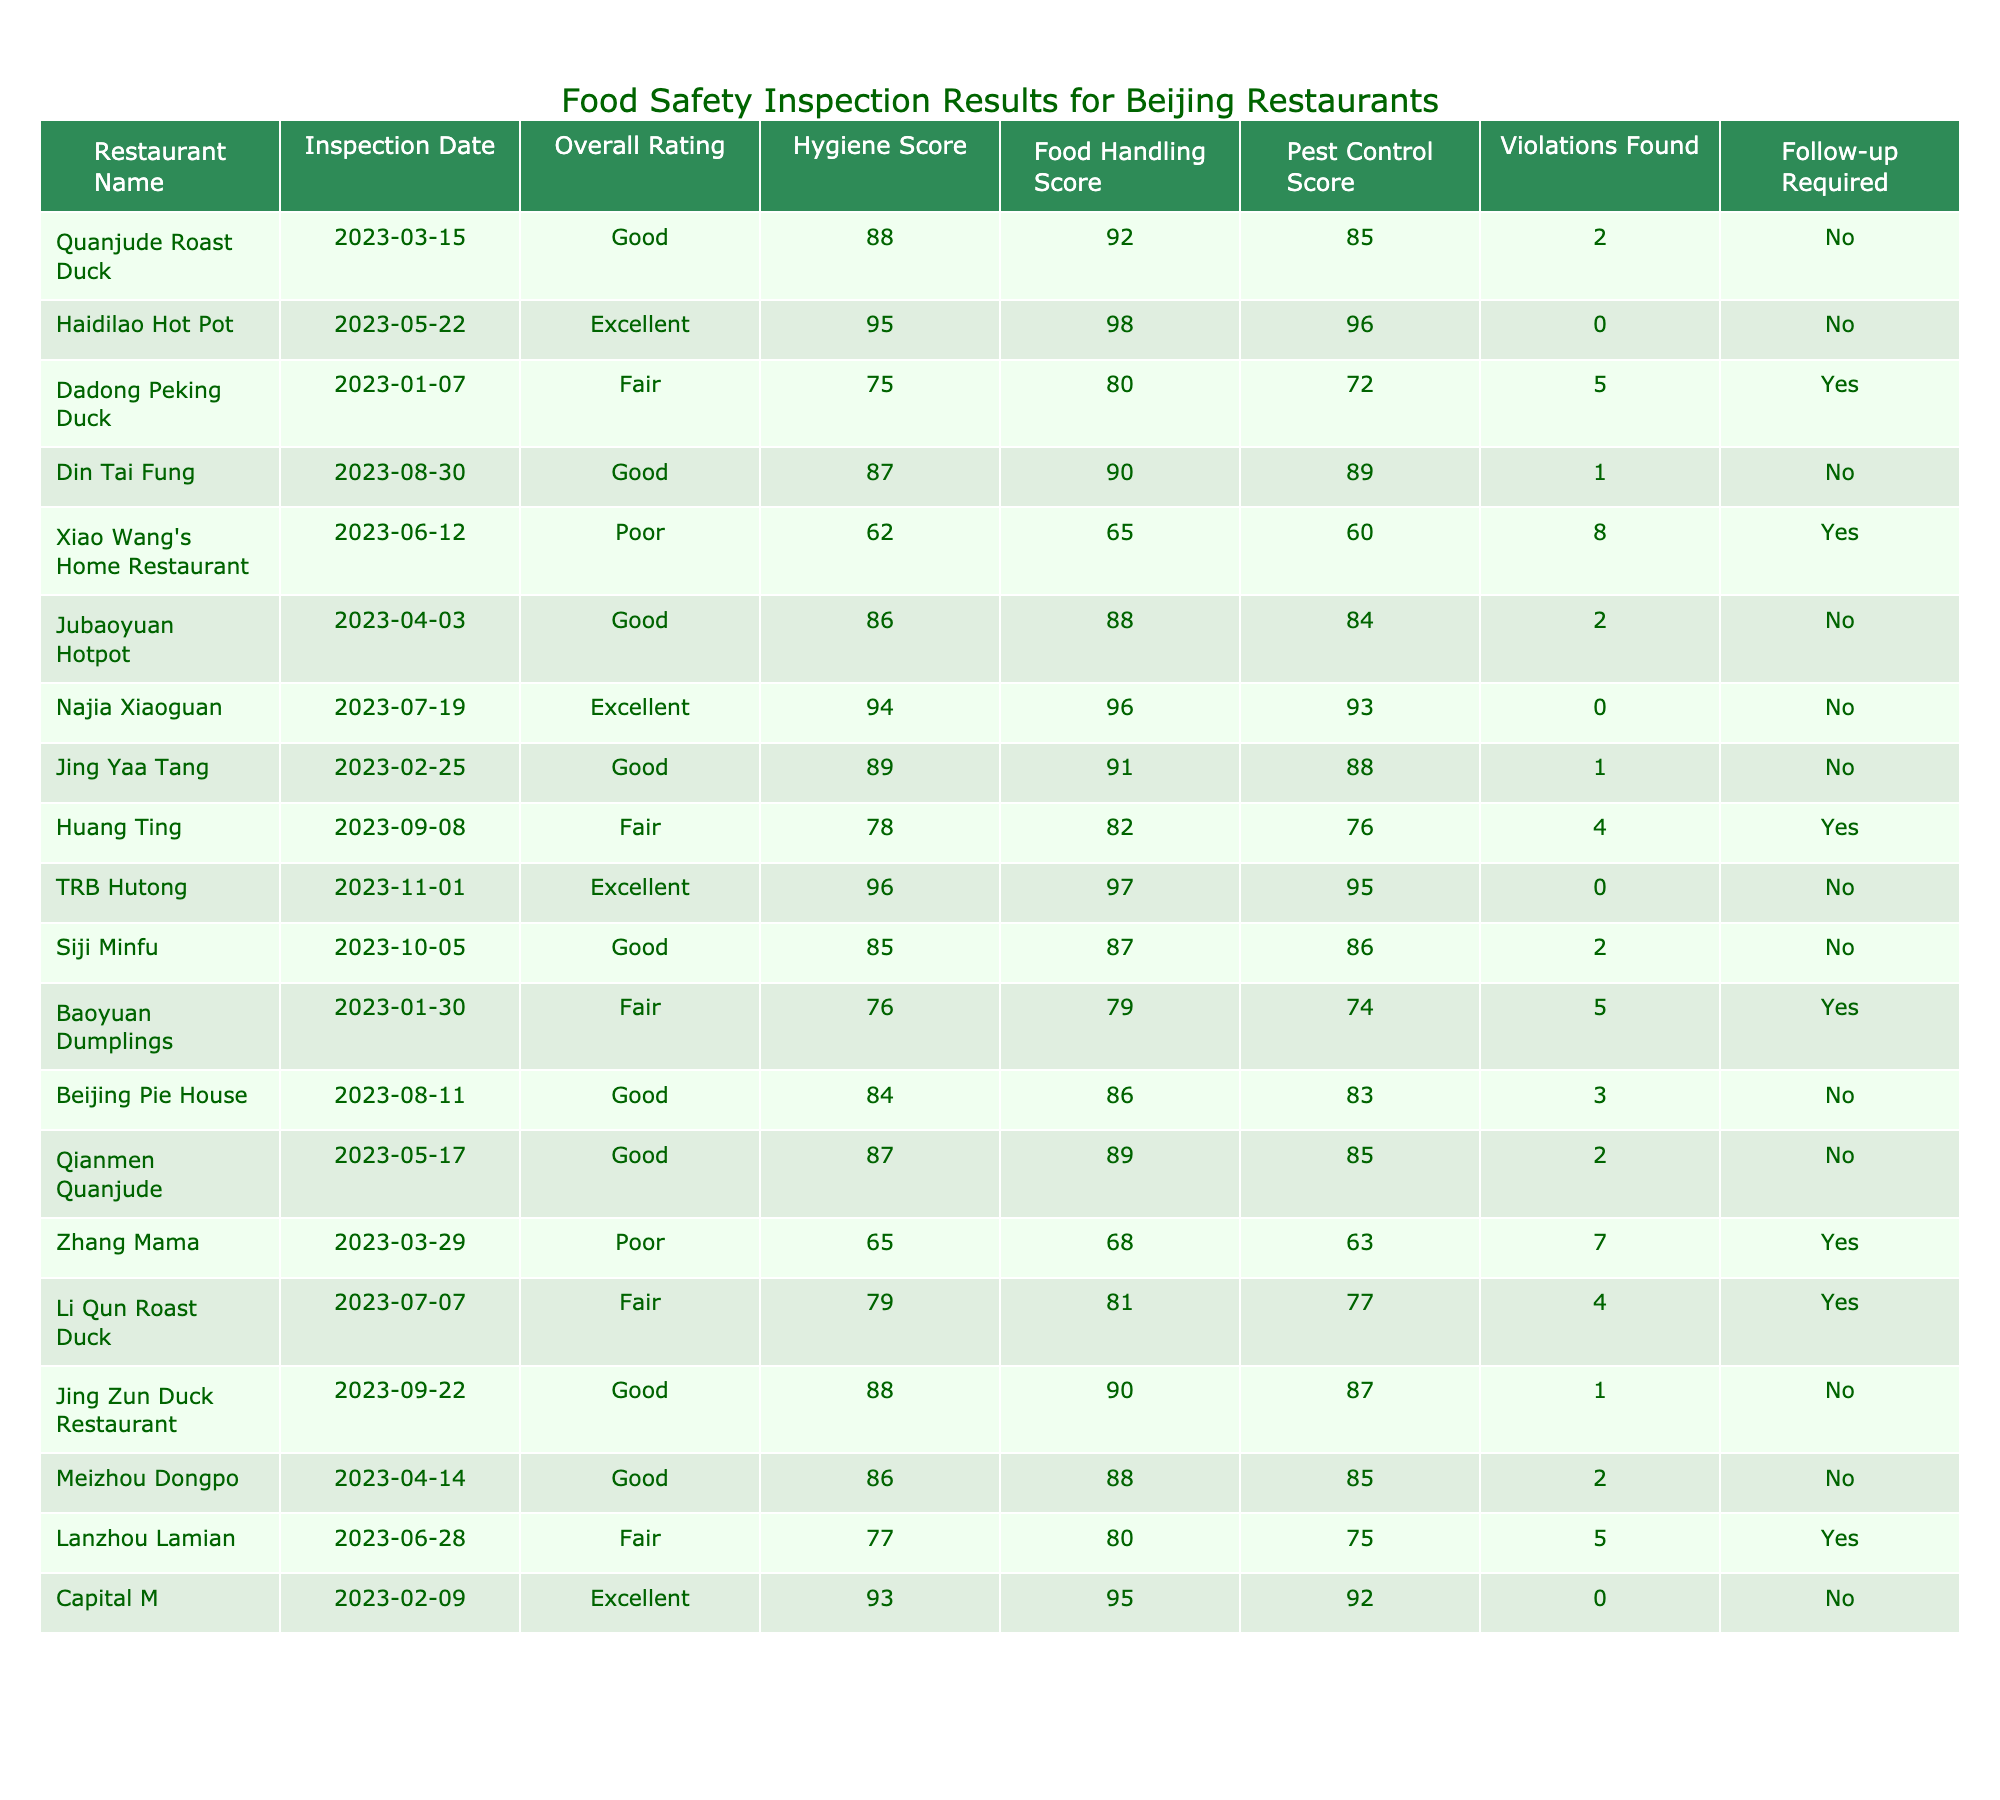What is the overall rating of Haidilao Hot Pot? Haidilao Hot Pot has an overall rating of 'Excellent' as indicated in its entry in the table.
Answer: Excellent How many restaurants require follow-up inspections? Two restaurants, Dadong Peking Duck and Xiao Wang's Home Restaurant, require follow-up inspections as marked in the table.
Answer: 2 What is the highest hygiene score recorded in the table? The highest hygiene score is 98, which belongs to Haidilao Hot Pot.
Answer: 98 What is the average Food Handling Score for the restaurants rated 'Good'? The food handling scores for restaurants rated 'Good' are 92, 89, 90, 88, 87, 88, 86. The average is (92 + 89 + 90 + 88 + 87 + 88 + 86) / 7 = 88.57.
Answer: 88.57 Which restaurant had the most violations found? Xiao Wang's Home Restaurant had the most violations found, with a total of 8 violations indicated in the table.
Answer: Xiao Wang's Home Restaurant Is the statement "All restaurants rated 'Poor' require follow-up inspections" true? Yes, both restaurants rated 'Poor' (Xiao Wang's Home Restaurant and Zhang Mama) require follow-up inspections as shown in the table.
Answer: Yes Determine the difference in Pest Control Scores between the highest and lowest rated restaurants. The highest rated restaurant is Haidilao Hot Pot with a Pest Control Score of 96, and the lowest rated is Xiao Wang's Home Restaurant with a Pest Control Score of 60. The difference is 96 - 60 = 36.
Answer: 36 How many restaurants have an Excellent rating and did not require a follow-up inspection? There are four restaurants with an Excellent rating that did not require a follow-up inspection: Haidilao Hot Pot, Najia Xiaoguan, Capital M, and TRB Hutong.
Answer: 4 What percentage of restaurants inspected had a Fair rating? There are three restaurants with a Fair rating (Dadong Peking Duck, Li Qun Roast Duck, and Baoyuan Dumplings) out of a total of 17 restaurants. The percentage is (3/17) * 100 = 17.65%.
Answer: 17.65% List the names of restaurants with a Good rating that have follow-up inspections required. The only restaurant rated 'Good' that requires a follow-up inspection is Din Tai Fung.
Answer: Din Tai Fung Which restaurant has the lowest overall rating? Xiao Wang's Home Restaurant has the lowest overall rating, which is 'Poor'.
Answer: Xiao Wang's Home Restaurant 